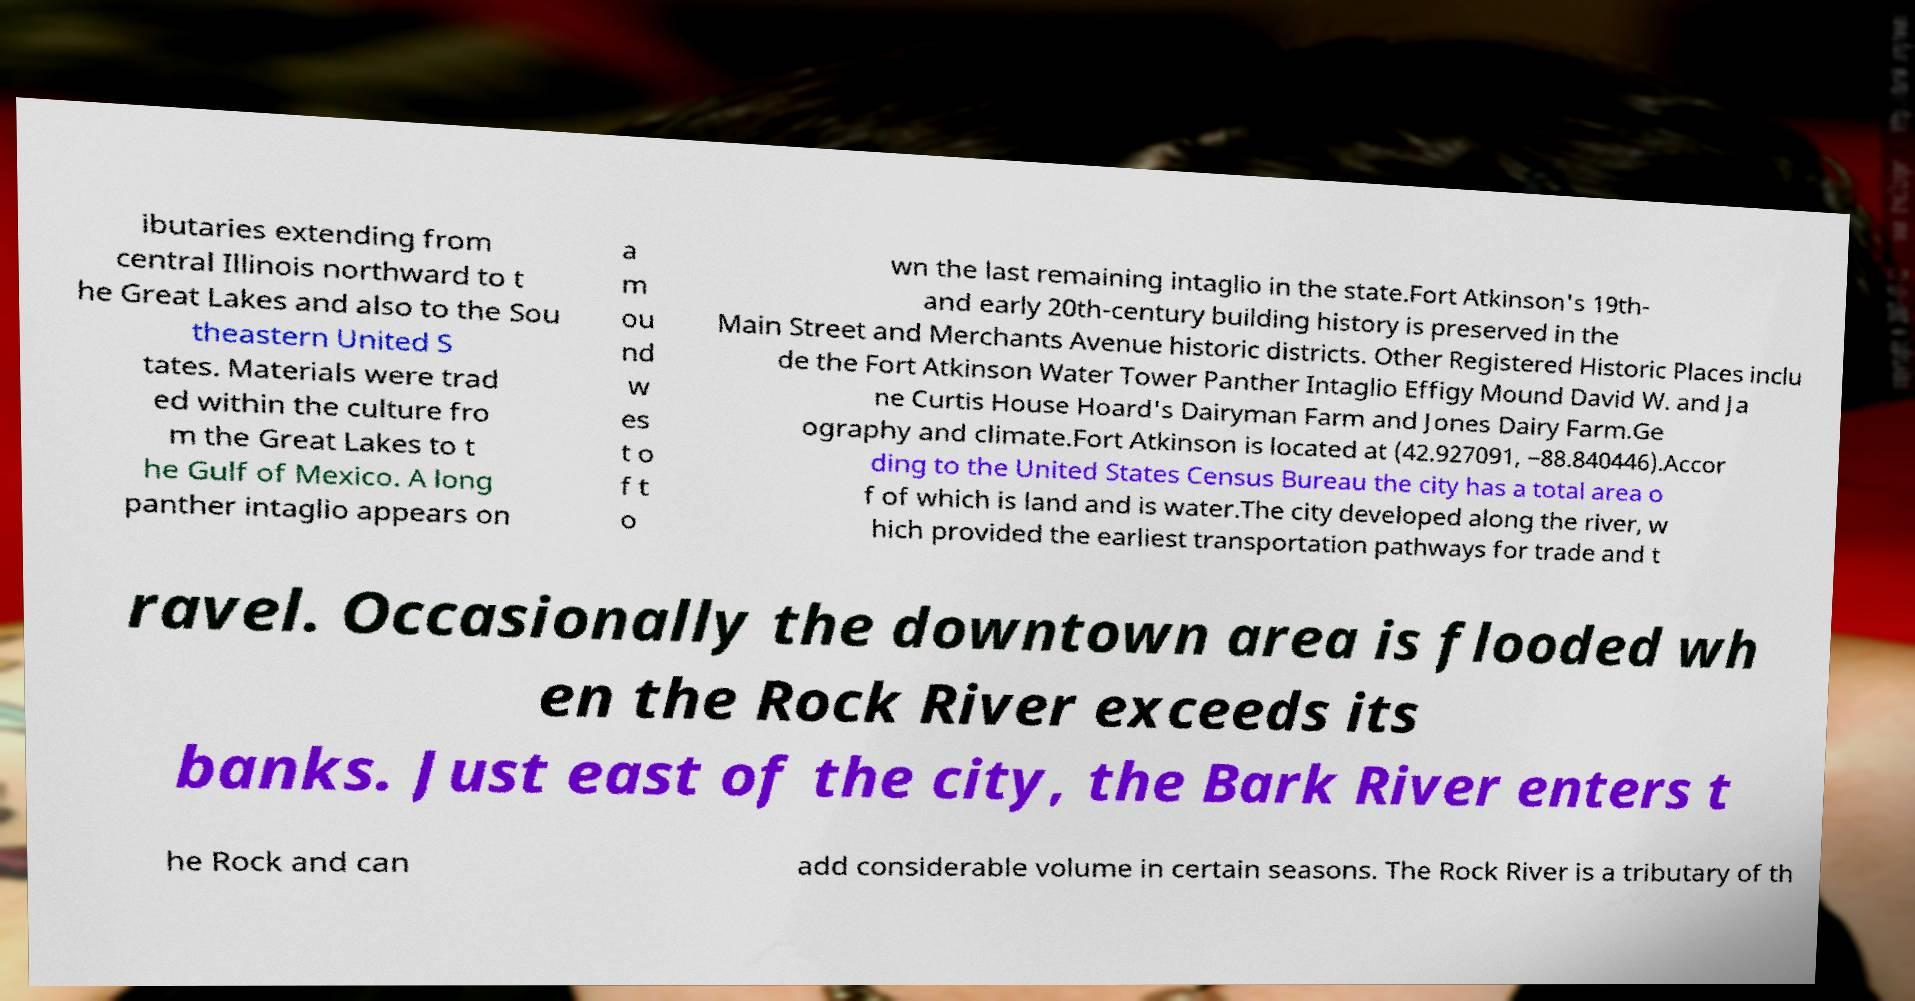For documentation purposes, I need the text within this image transcribed. Could you provide that? ibutaries extending from central Illinois northward to t he Great Lakes and also to the Sou theastern United S tates. Materials were trad ed within the culture fro m the Great Lakes to t he Gulf of Mexico. A long panther intaglio appears on a m ou nd w es t o f t o wn the last remaining intaglio in the state.Fort Atkinson's 19th- and early 20th-century building history is preserved in the Main Street and Merchants Avenue historic districts. Other Registered Historic Places inclu de the Fort Atkinson Water Tower Panther Intaglio Effigy Mound David W. and Ja ne Curtis House Hoard's Dairyman Farm and Jones Dairy Farm.Ge ography and climate.Fort Atkinson is located at (42.927091, −88.840446).Accor ding to the United States Census Bureau the city has a total area o f of which is land and is water.The city developed along the river, w hich provided the earliest transportation pathways for trade and t ravel. Occasionally the downtown area is flooded wh en the Rock River exceeds its banks. Just east of the city, the Bark River enters t he Rock and can add considerable volume in certain seasons. The Rock River is a tributary of th 